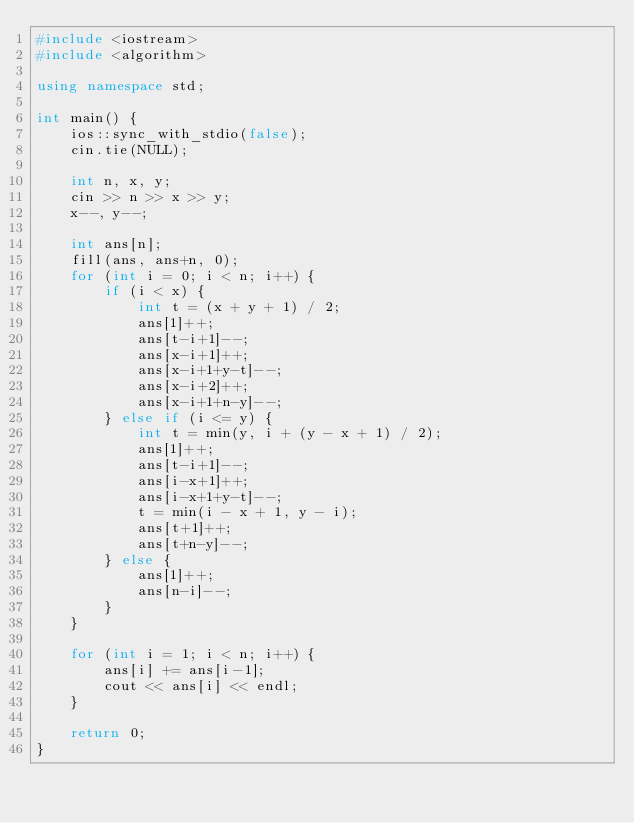<code> <loc_0><loc_0><loc_500><loc_500><_C++_>#include <iostream>
#include <algorithm>

using namespace std;

int main() {
    ios::sync_with_stdio(false);
    cin.tie(NULL);

    int n, x, y;
    cin >> n >> x >> y;
    x--, y--;

    int ans[n];
    fill(ans, ans+n, 0);
    for (int i = 0; i < n; i++) {
        if (i < x) {
            int t = (x + y + 1) / 2;
            ans[1]++;
            ans[t-i+1]--;
            ans[x-i+1]++;
            ans[x-i+1+y-t]--;
            ans[x-i+2]++;
            ans[x-i+1+n-y]--;
        } else if (i <= y) {
            int t = min(y, i + (y - x + 1) / 2);
            ans[1]++;
            ans[t-i+1]--;
            ans[i-x+1]++;
            ans[i-x+1+y-t]--;
            t = min(i - x + 1, y - i);
            ans[t+1]++;
            ans[t+n-y]--;
        } else {
            ans[1]++;
            ans[n-i]--;
        }
    }

    for (int i = 1; i < n; i++) {
        ans[i] += ans[i-1];
        cout << ans[i] << endl;
    }

    return 0;
}
</code> 